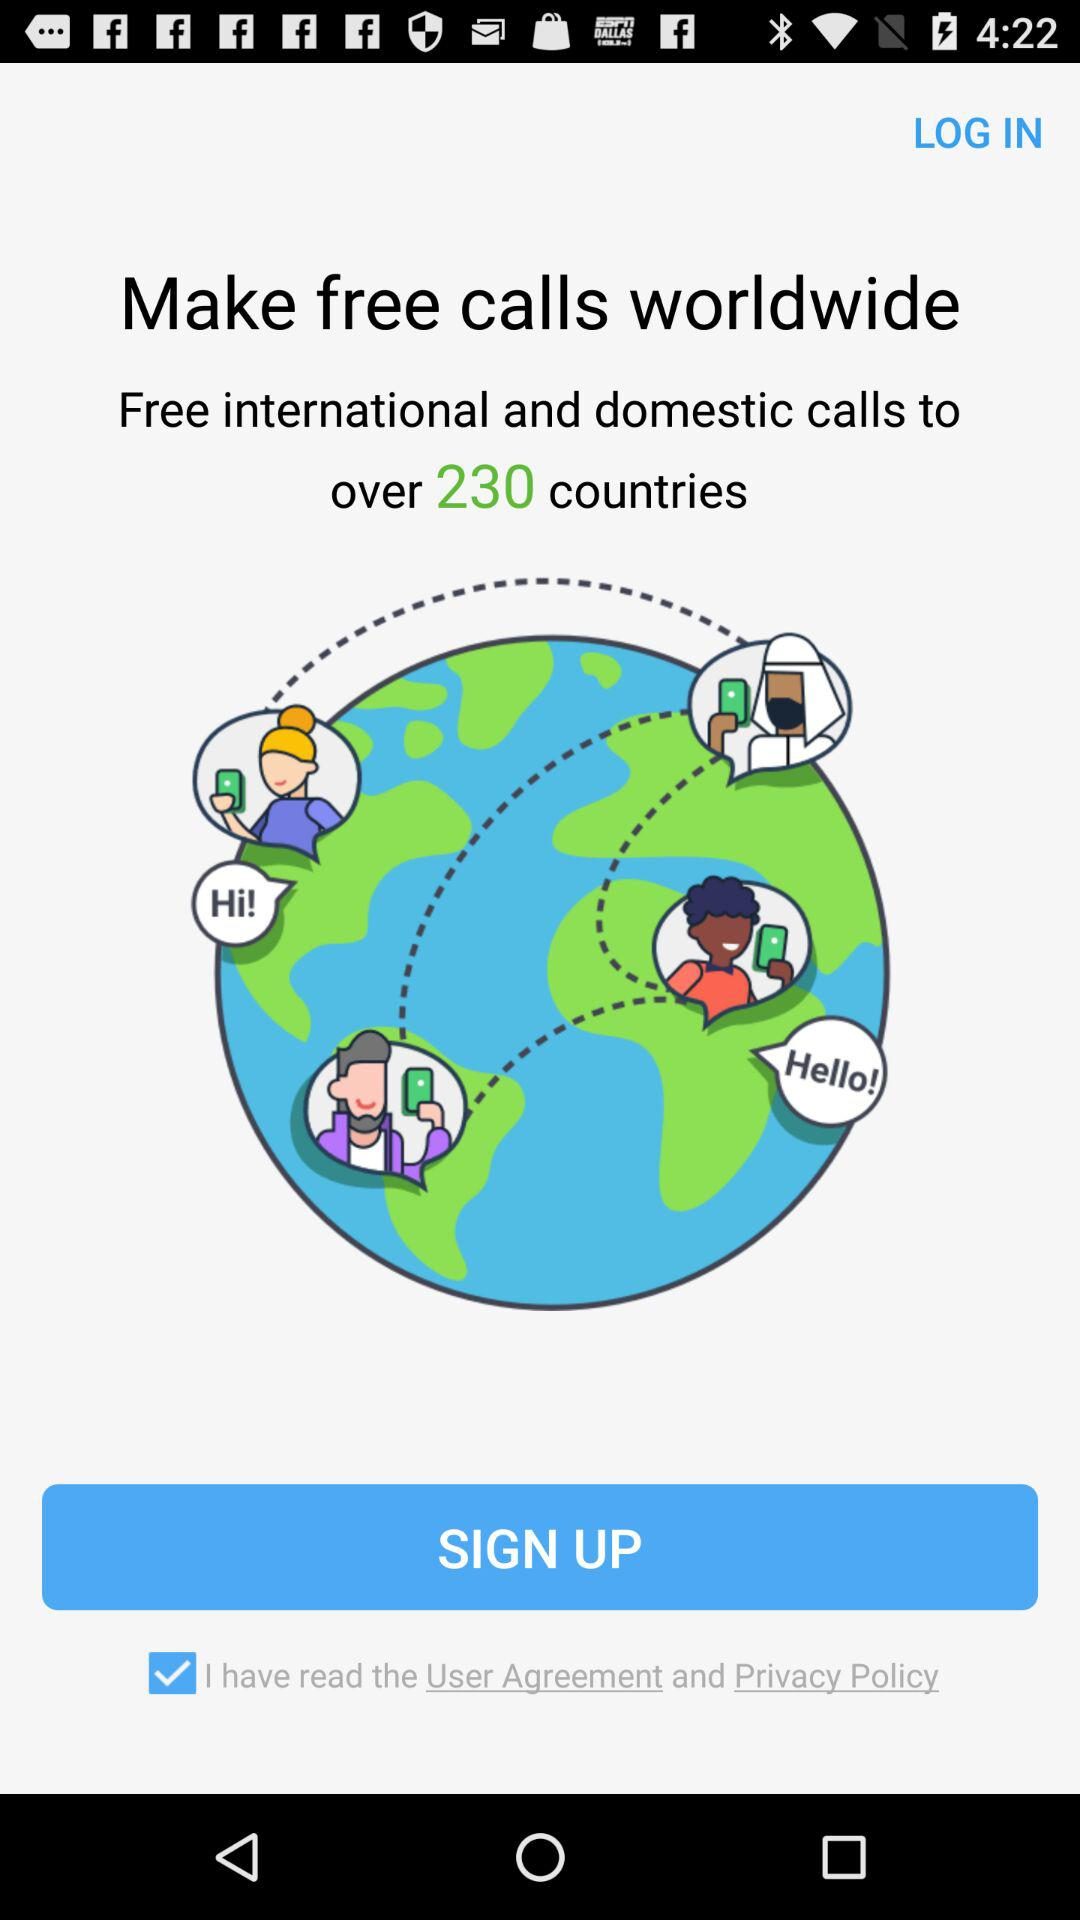Which option is checked? The checked option is "I have read the User Agreement and Privacy Policy". 